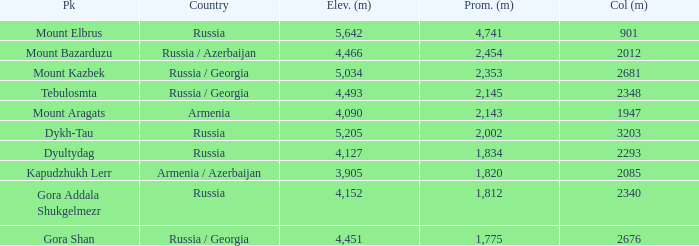With a Col (m) larger than 2012, what is Mount Kazbek's Prominence (m)? 2353.0. 